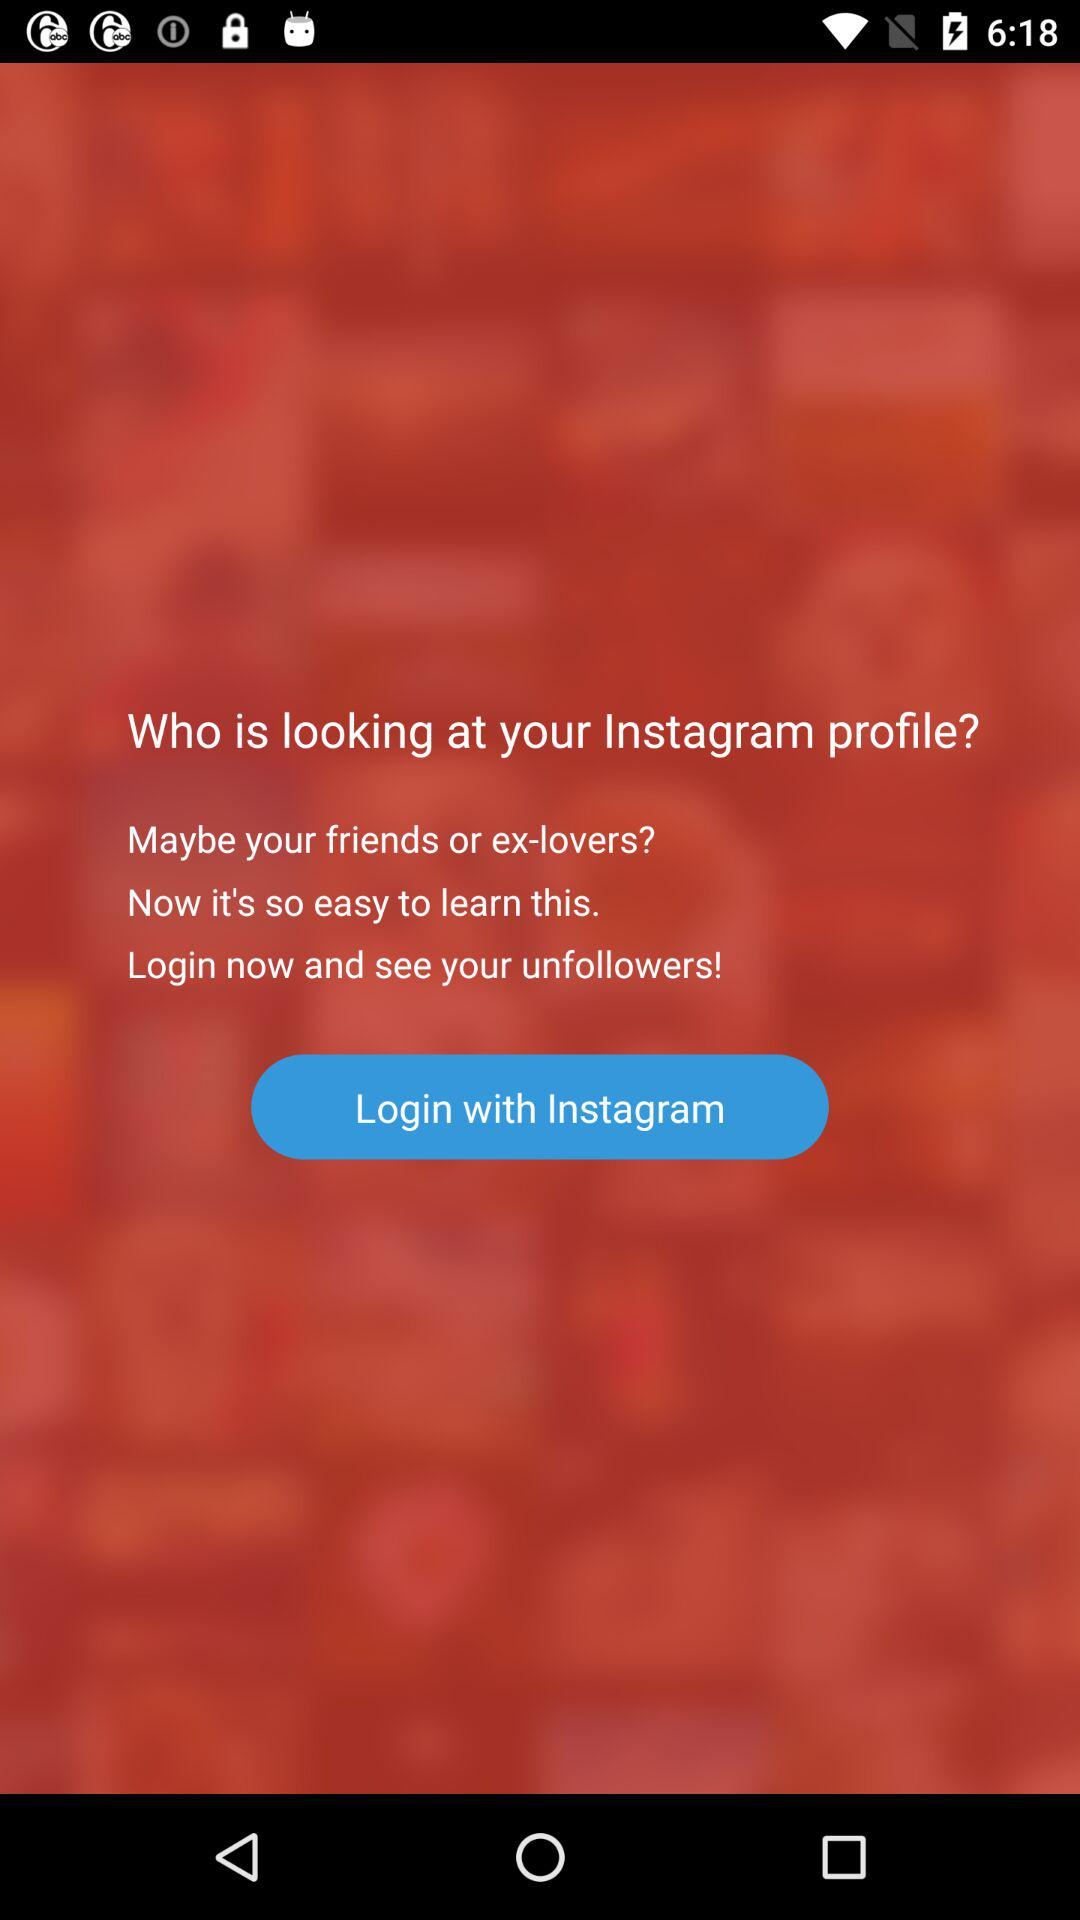What is the name of the application?
When the provided information is insufficient, respond with <no answer>. <no answer> 